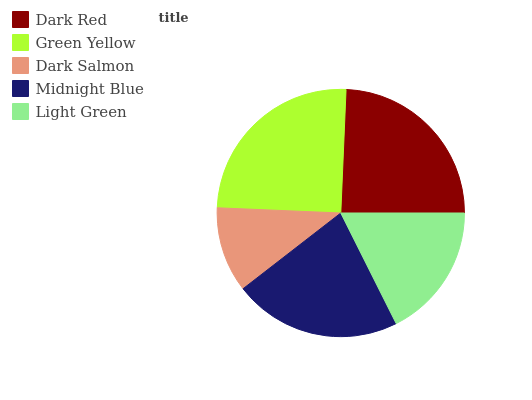Is Dark Salmon the minimum?
Answer yes or no. Yes. Is Green Yellow the maximum?
Answer yes or no. Yes. Is Green Yellow the minimum?
Answer yes or no. No. Is Dark Salmon the maximum?
Answer yes or no. No. Is Green Yellow greater than Dark Salmon?
Answer yes or no. Yes. Is Dark Salmon less than Green Yellow?
Answer yes or no. Yes. Is Dark Salmon greater than Green Yellow?
Answer yes or no. No. Is Green Yellow less than Dark Salmon?
Answer yes or no. No. Is Midnight Blue the high median?
Answer yes or no. Yes. Is Midnight Blue the low median?
Answer yes or no. Yes. Is Dark Salmon the high median?
Answer yes or no. No. Is Dark Red the low median?
Answer yes or no. No. 